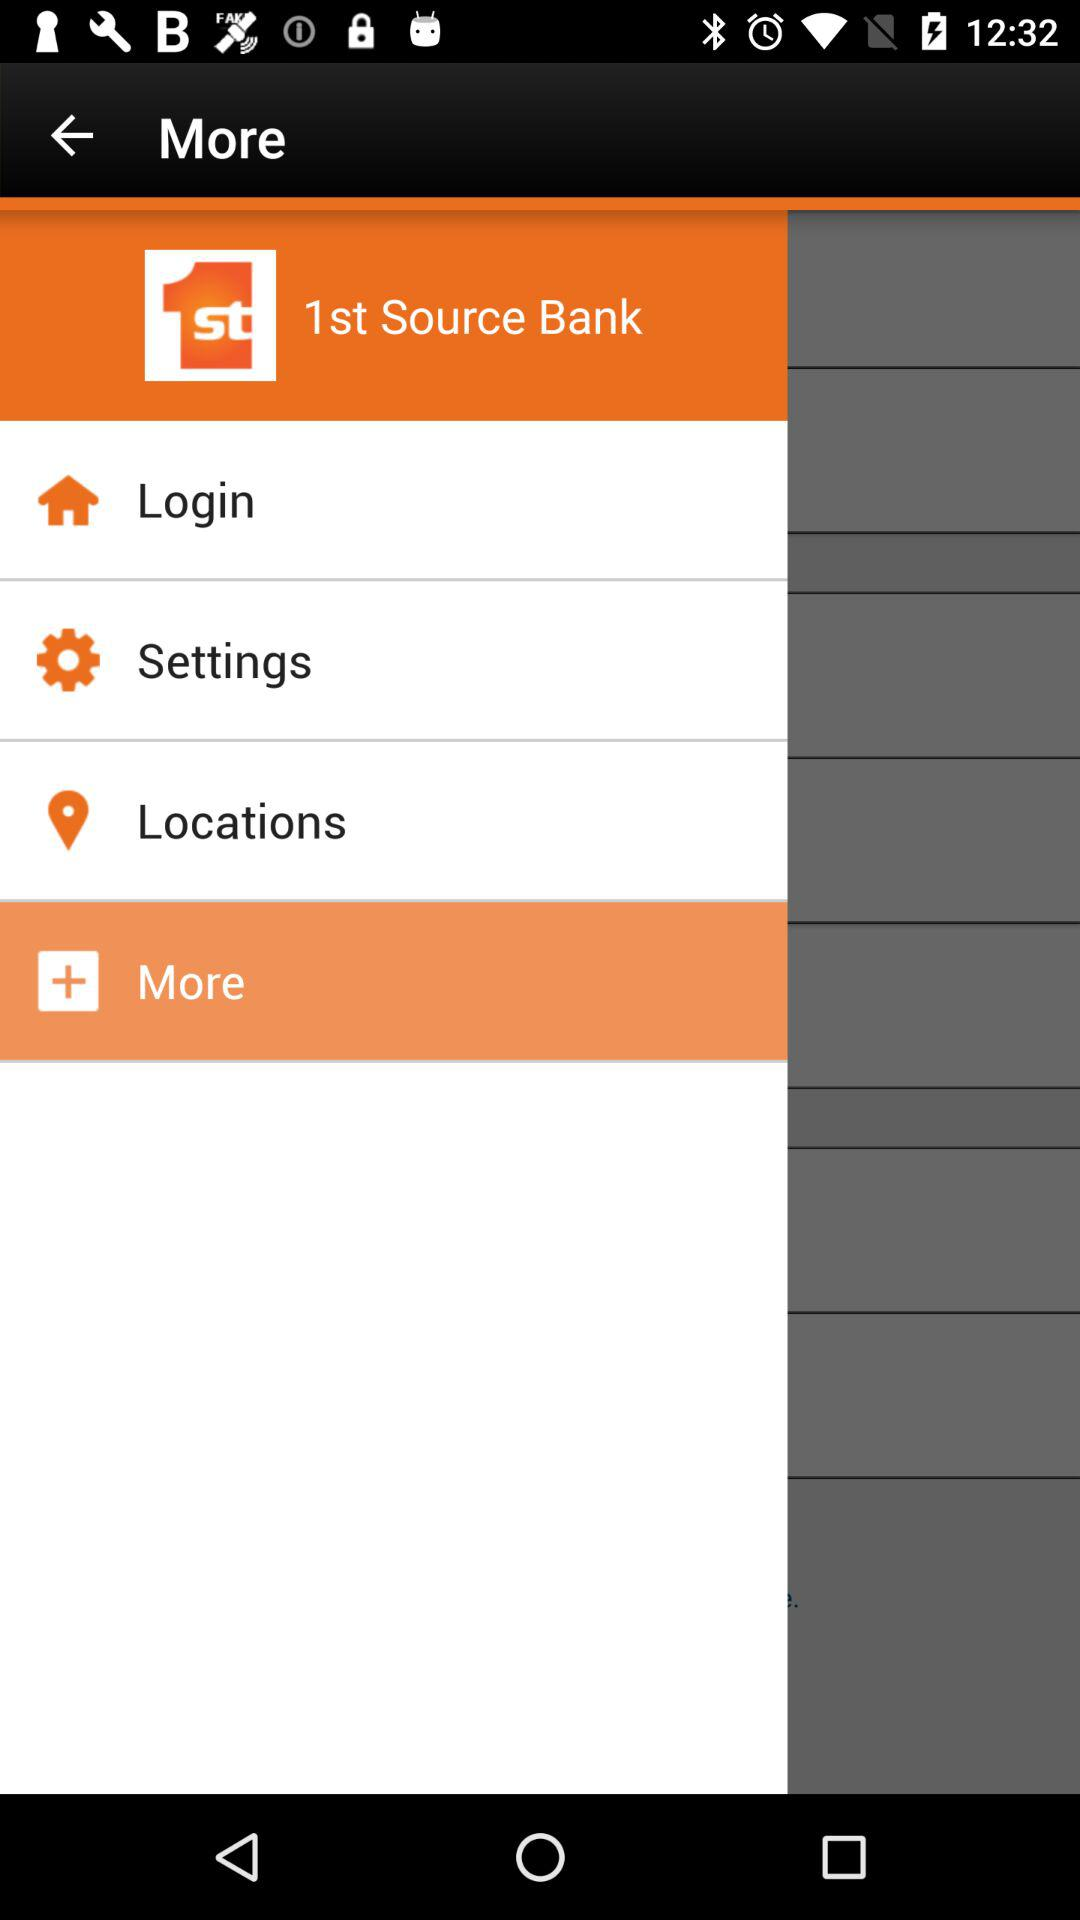What is the application name? The name of the application is "1st Source Bank". 